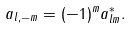<formula> <loc_0><loc_0><loc_500><loc_500>a _ { l , - m } = ( - 1 ) ^ { m } a _ { l m } ^ { * } .</formula> 